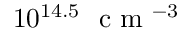Convert formula to latex. <formula><loc_0><loc_0><loc_500><loc_500>1 0 ^ { 1 4 . 5 } c m ^ { - 3 }</formula> 